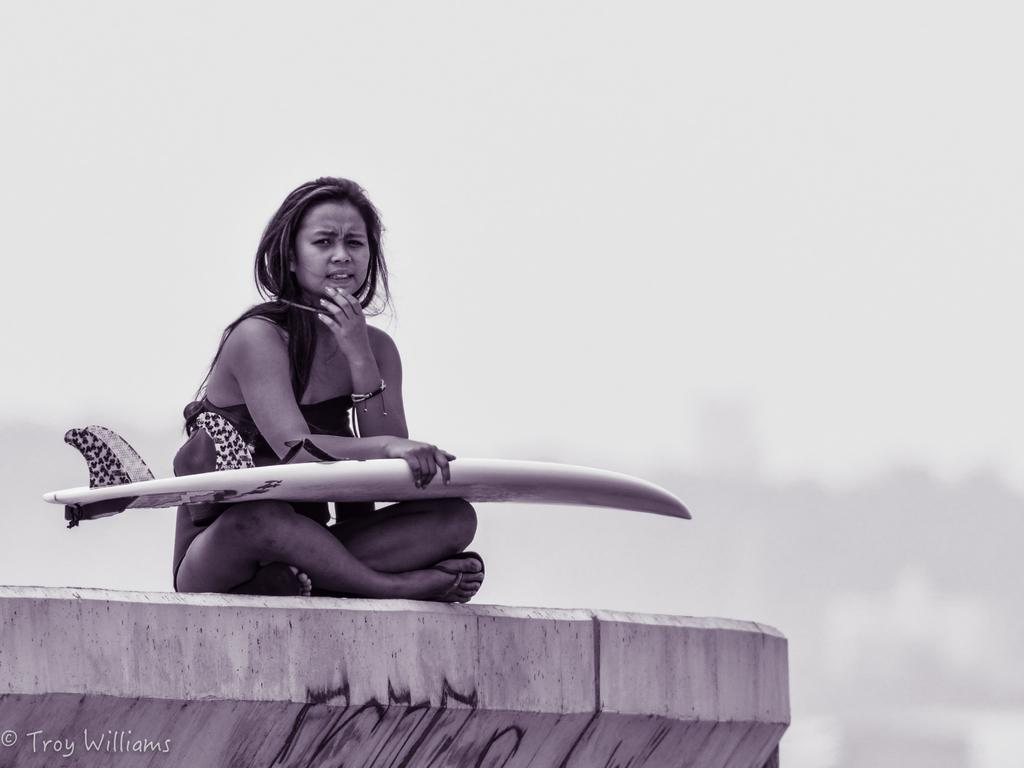What is the possible location of the image? The image might be taken on a shore. Can you describe the main subject in the image? A woman is sitting in the center of the picture. What is the woman holding in the image? The woman is holding a surfboard. What can be seen in the background of the image? There is sky visible in the background of the image. How many keys are hanging from the woman's neck in the image? There are no keys visible in the image; the woman is holding a surfboard. 